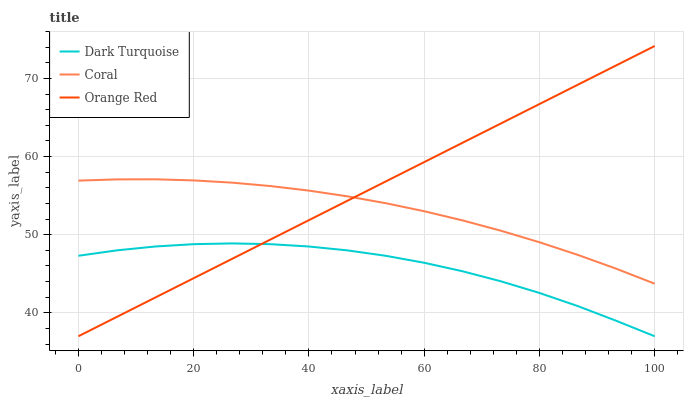Does Coral have the minimum area under the curve?
Answer yes or no. No. Does Coral have the maximum area under the curve?
Answer yes or no. No. Is Coral the smoothest?
Answer yes or no. No. Is Coral the roughest?
Answer yes or no. No. Does Coral have the lowest value?
Answer yes or no. No. Does Coral have the highest value?
Answer yes or no. No. Is Dark Turquoise less than Coral?
Answer yes or no. Yes. Is Coral greater than Dark Turquoise?
Answer yes or no. Yes. Does Dark Turquoise intersect Coral?
Answer yes or no. No. 